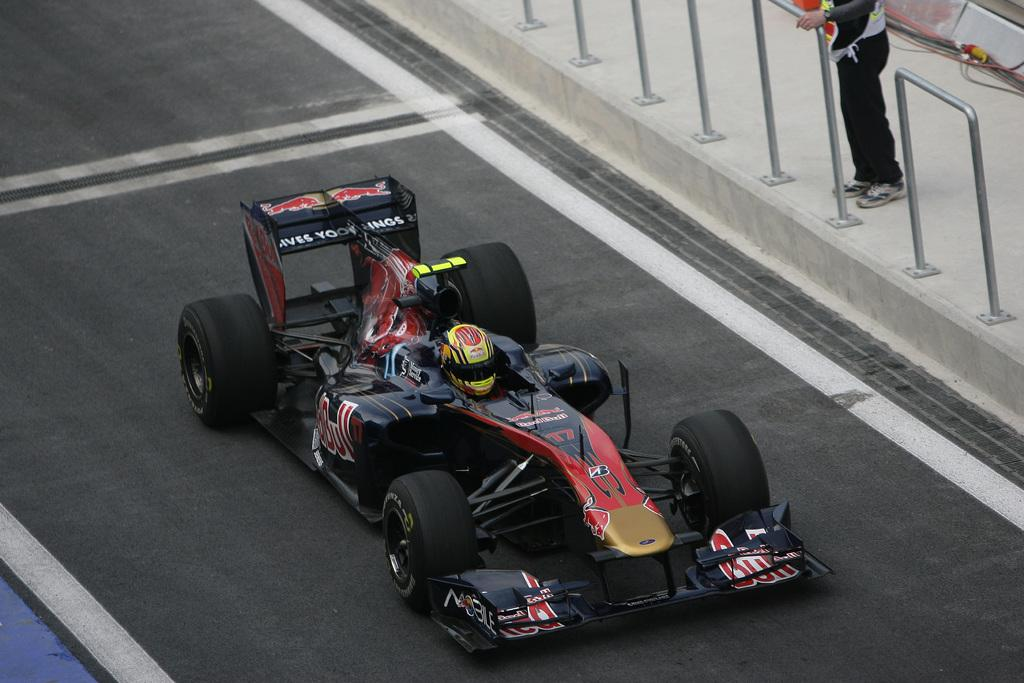What is the person in the image doing? There is a person sitting in a vehicle in the image. What color is the vehicle? The vehicle is black. Can you describe the background of the image? There is a person standing in the background, and there are poles visible in the background. What type of shelf can be seen in the image? There is no shelf present in the image. Can you tell me what health issues the person standing in the background might have? There is no information about the health of the person standing in the background, as it is not mentioned in the image or the provided facts. 